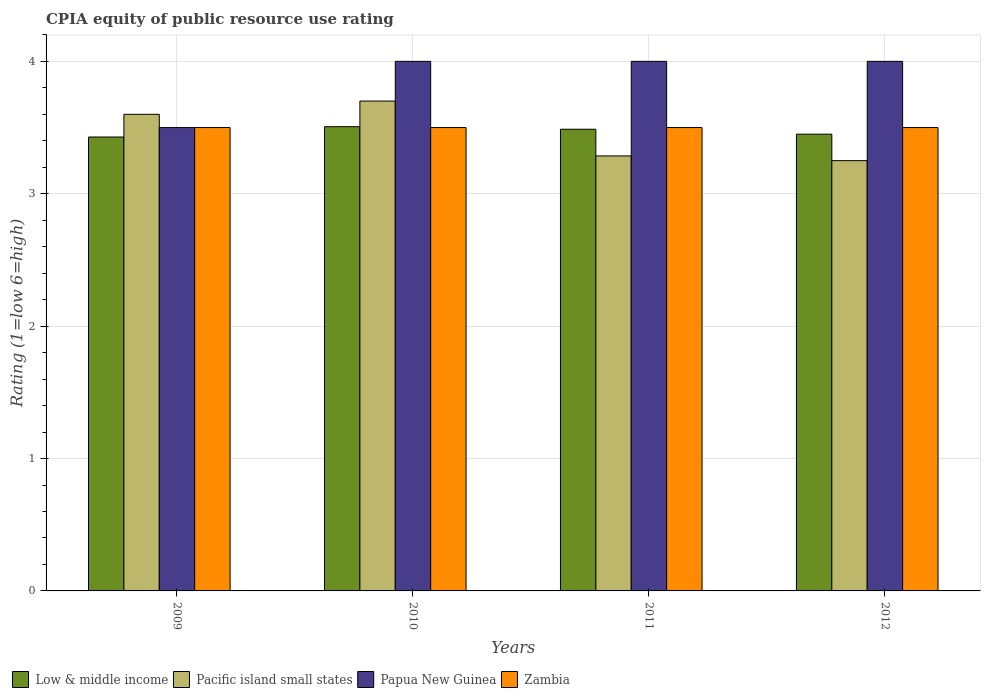Are the number of bars per tick equal to the number of legend labels?
Keep it short and to the point. Yes. Are the number of bars on each tick of the X-axis equal?
Offer a very short reply. Yes. What is the CPIA rating in Papua New Guinea in 2010?
Keep it short and to the point. 4. Across all years, what is the maximum CPIA rating in Low & middle income?
Provide a succinct answer. 3.51. Across all years, what is the minimum CPIA rating in Zambia?
Make the answer very short. 3.5. In which year was the CPIA rating in Papua New Guinea maximum?
Your answer should be compact. 2010. What is the total CPIA rating in Zambia in the graph?
Offer a terse response. 14. What is the difference between the CPIA rating in Zambia in 2010 and that in 2011?
Ensure brevity in your answer.  0. What is the difference between the CPIA rating in Papua New Guinea in 2011 and the CPIA rating in Zambia in 2012?
Provide a short and direct response. 0.5. What is the average CPIA rating in Pacific island small states per year?
Give a very brief answer. 3.46. In the year 2009, what is the difference between the CPIA rating in Zambia and CPIA rating in Pacific island small states?
Make the answer very short. -0.1. In how many years, is the CPIA rating in Zambia greater than 3.8?
Give a very brief answer. 0. Is the CPIA rating in Pacific island small states in 2009 less than that in 2011?
Make the answer very short. No. Is the difference between the CPIA rating in Zambia in 2009 and 2010 greater than the difference between the CPIA rating in Pacific island small states in 2009 and 2010?
Your answer should be compact. Yes. What is the difference between the highest and the second highest CPIA rating in Zambia?
Provide a succinct answer. 0. What is the difference between the highest and the lowest CPIA rating in Papua New Guinea?
Provide a short and direct response. 0.5. What does the 4th bar from the right in 2012 represents?
Offer a very short reply. Low & middle income. How many bars are there?
Provide a succinct answer. 16. Are all the bars in the graph horizontal?
Your response must be concise. No. Are the values on the major ticks of Y-axis written in scientific E-notation?
Ensure brevity in your answer.  No. Where does the legend appear in the graph?
Make the answer very short. Bottom left. How many legend labels are there?
Provide a succinct answer. 4. What is the title of the graph?
Your answer should be very brief. CPIA equity of public resource use rating. Does "Mongolia" appear as one of the legend labels in the graph?
Offer a terse response. No. What is the label or title of the Y-axis?
Keep it short and to the point. Rating (1=low 6=high). What is the Rating (1=low 6=high) in Low & middle income in 2009?
Keep it short and to the point. 3.43. What is the Rating (1=low 6=high) of Papua New Guinea in 2009?
Keep it short and to the point. 3.5. What is the Rating (1=low 6=high) of Zambia in 2009?
Give a very brief answer. 3.5. What is the Rating (1=low 6=high) in Low & middle income in 2010?
Give a very brief answer. 3.51. What is the Rating (1=low 6=high) of Papua New Guinea in 2010?
Provide a succinct answer. 4. What is the Rating (1=low 6=high) of Zambia in 2010?
Your answer should be compact. 3.5. What is the Rating (1=low 6=high) of Low & middle income in 2011?
Provide a short and direct response. 3.49. What is the Rating (1=low 6=high) of Pacific island small states in 2011?
Ensure brevity in your answer.  3.29. What is the Rating (1=low 6=high) in Papua New Guinea in 2011?
Your answer should be compact. 4. What is the Rating (1=low 6=high) of Low & middle income in 2012?
Ensure brevity in your answer.  3.45. What is the Rating (1=low 6=high) in Pacific island small states in 2012?
Keep it short and to the point. 3.25. What is the Rating (1=low 6=high) of Papua New Guinea in 2012?
Give a very brief answer. 4. What is the Rating (1=low 6=high) in Zambia in 2012?
Your response must be concise. 3.5. Across all years, what is the maximum Rating (1=low 6=high) of Low & middle income?
Ensure brevity in your answer.  3.51. Across all years, what is the maximum Rating (1=low 6=high) in Pacific island small states?
Provide a succinct answer. 3.7. Across all years, what is the maximum Rating (1=low 6=high) of Papua New Guinea?
Offer a terse response. 4. Across all years, what is the maximum Rating (1=low 6=high) in Zambia?
Give a very brief answer. 3.5. Across all years, what is the minimum Rating (1=low 6=high) of Low & middle income?
Make the answer very short. 3.43. Across all years, what is the minimum Rating (1=low 6=high) in Pacific island small states?
Ensure brevity in your answer.  3.25. What is the total Rating (1=low 6=high) of Low & middle income in the graph?
Your answer should be compact. 13.87. What is the total Rating (1=low 6=high) of Pacific island small states in the graph?
Ensure brevity in your answer.  13.84. What is the difference between the Rating (1=low 6=high) in Low & middle income in 2009 and that in 2010?
Provide a succinct answer. -0.08. What is the difference between the Rating (1=low 6=high) of Low & middle income in 2009 and that in 2011?
Your answer should be compact. -0.06. What is the difference between the Rating (1=low 6=high) of Pacific island small states in 2009 and that in 2011?
Make the answer very short. 0.31. What is the difference between the Rating (1=low 6=high) in Zambia in 2009 and that in 2011?
Provide a succinct answer. 0. What is the difference between the Rating (1=low 6=high) in Low & middle income in 2009 and that in 2012?
Your answer should be very brief. -0.02. What is the difference between the Rating (1=low 6=high) of Papua New Guinea in 2009 and that in 2012?
Provide a short and direct response. -0.5. What is the difference between the Rating (1=low 6=high) of Low & middle income in 2010 and that in 2011?
Give a very brief answer. 0.02. What is the difference between the Rating (1=low 6=high) in Pacific island small states in 2010 and that in 2011?
Provide a short and direct response. 0.41. What is the difference between the Rating (1=low 6=high) in Papua New Guinea in 2010 and that in 2011?
Your answer should be compact. 0. What is the difference between the Rating (1=low 6=high) of Low & middle income in 2010 and that in 2012?
Your answer should be very brief. 0.06. What is the difference between the Rating (1=low 6=high) in Pacific island small states in 2010 and that in 2012?
Keep it short and to the point. 0.45. What is the difference between the Rating (1=low 6=high) of Low & middle income in 2011 and that in 2012?
Offer a terse response. 0.04. What is the difference between the Rating (1=low 6=high) in Pacific island small states in 2011 and that in 2012?
Keep it short and to the point. 0.04. What is the difference between the Rating (1=low 6=high) in Zambia in 2011 and that in 2012?
Provide a succinct answer. 0. What is the difference between the Rating (1=low 6=high) in Low & middle income in 2009 and the Rating (1=low 6=high) in Pacific island small states in 2010?
Keep it short and to the point. -0.27. What is the difference between the Rating (1=low 6=high) in Low & middle income in 2009 and the Rating (1=low 6=high) in Papua New Guinea in 2010?
Provide a short and direct response. -0.57. What is the difference between the Rating (1=low 6=high) in Low & middle income in 2009 and the Rating (1=low 6=high) in Zambia in 2010?
Provide a short and direct response. -0.07. What is the difference between the Rating (1=low 6=high) of Pacific island small states in 2009 and the Rating (1=low 6=high) of Zambia in 2010?
Give a very brief answer. 0.1. What is the difference between the Rating (1=low 6=high) in Papua New Guinea in 2009 and the Rating (1=low 6=high) in Zambia in 2010?
Ensure brevity in your answer.  0. What is the difference between the Rating (1=low 6=high) in Low & middle income in 2009 and the Rating (1=low 6=high) in Pacific island small states in 2011?
Offer a very short reply. 0.14. What is the difference between the Rating (1=low 6=high) of Low & middle income in 2009 and the Rating (1=low 6=high) of Papua New Guinea in 2011?
Provide a short and direct response. -0.57. What is the difference between the Rating (1=low 6=high) in Low & middle income in 2009 and the Rating (1=low 6=high) in Zambia in 2011?
Offer a terse response. -0.07. What is the difference between the Rating (1=low 6=high) of Pacific island small states in 2009 and the Rating (1=low 6=high) of Papua New Guinea in 2011?
Your answer should be compact. -0.4. What is the difference between the Rating (1=low 6=high) of Papua New Guinea in 2009 and the Rating (1=low 6=high) of Zambia in 2011?
Keep it short and to the point. 0. What is the difference between the Rating (1=low 6=high) of Low & middle income in 2009 and the Rating (1=low 6=high) of Pacific island small states in 2012?
Ensure brevity in your answer.  0.18. What is the difference between the Rating (1=low 6=high) of Low & middle income in 2009 and the Rating (1=low 6=high) of Papua New Guinea in 2012?
Give a very brief answer. -0.57. What is the difference between the Rating (1=low 6=high) of Low & middle income in 2009 and the Rating (1=low 6=high) of Zambia in 2012?
Your answer should be very brief. -0.07. What is the difference between the Rating (1=low 6=high) of Low & middle income in 2010 and the Rating (1=low 6=high) of Pacific island small states in 2011?
Make the answer very short. 0.22. What is the difference between the Rating (1=low 6=high) of Low & middle income in 2010 and the Rating (1=low 6=high) of Papua New Guinea in 2011?
Your response must be concise. -0.49. What is the difference between the Rating (1=low 6=high) in Low & middle income in 2010 and the Rating (1=low 6=high) in Zambia in 2011?
Ensure brevity in your answer.  0.01. What is the difference between the Rating (1=low 6=high) of Pacific island small states in 2010 and the Rating (1=low 6=high) of Papua New Guinea in 2011?
Offer a terse response. -0.3. What is the difference between the Rating (1=low 6=high) in Pacific island small states in 2010 and the Rating (1=low 6=high) in Zambia in 2011?
Your answer should be very brief. 0.2. What is the difference between the Rating (1=low 6=high) in Papua New Guinea in 2010 and the Rating (1=low 6=high) in Zambia in 2011?
Ensure brevity in your answer.  0.5. What is the difference between the Rating (1=low 6=high) of Low & middle income in 2010 and the Rating (1=low 6=high) of Pacific island small states in 2012?
Your answer should be very brief. 0.26. What is the difference between the Rating (1=low 6=high) of Low & middle income in 2010 and the Rating (1=low 6=high) of Papua New Guinea in 2012?
Give a very brief answer. -0.49. What is the difference between the Rating (1=low 6=high) in Low & middle income in 2010 and the Rating (1=low 6=high) in Zambia in 2012?
Ensure brevity in your answer.  0.01. What is the difference between the Rating (1=low 6=high) of Pacific island small states in 2010 and the Rating (1=low 6=high) of Zambia in 2012?
Offer a very short reply. 0.2. What is the difference between the Rating (1=low 6=high) of Papua New Guinea in 2010 and the Rating (1=low 6=high) of Zambia in 2012?
Offer a very short reply. 0.5. What is the difference between the Rating (1=low 6=high) in Low & middle income in 2011 and the Rating (1=low 6=high) in Pacific island small states in 2012?
Provide a short and direct response. 0.24. What is the difference between the Rating (1=low 6=high) in Low & middle income in 2011 and the Rating (1=low 6=high) in Papua New Guinea in 2012?
Ensure brevity in your answer.  -0.51. What is the difference between the Rating (1=low 6=high) of Low & middle income in 2011 and the Rating (1=low 6=high) of Zambia in 2012?
Offer a very short reply. -0.01. What is the difference between the Rating (1=low 6=high) of Pacific island small states in 2011 and the Rating (1=low 6=high) of Papua New Guinea in 2012?
Offer a terse response. -0.71. What is the difference between the Rating (1=low 6=high) of Pacific island small states in 2011 and the Rating (1=low 6=high) of Zambia in 2012?
Your answer should be very brief. -0.21. What is the difference between the Rating (1=low 6=high) in Papua New Guinea in 2011 and the Rating (1=low 6=high) in Zambia in 2012?
Your answer should be very brief. 0.5. What is the average Rating (1=low 6=high) in Low & middle income per year?
Give a very brief answer. 3.47. What is the average Rating (1=low 6=high) in Pacific island small states per year?
Your response must be concise. 3.46. What is the average Rating (1=low 6=high) of Papua New Guinea per year?
Make the answer very short. 3.88. In the year 2009, what is the difference between the Rating (1=low 6=high) of Low & middle income and Rating (1=low 6=high) of Pacific island small states?
Offer a terse response. -0.17. In the year 2009, what is the difference between the Rating (1=low 6=high) in Low & middle income and Rating (1=low 6=high) in Papua New Guinea?
Your response must be concise. -0.07. In the year 2009, what is the difference between the Rating (1=low 6=high) of Low & middle income and Rating (1=low 6=high) of Zambia?
Offer a very short reply. -0.07. In the year 2009, what is the difference between the Rating (1=low 6=high) of Pacific island small states and Rating (1=low 6=high) of Papua New Guinea?
Offer a terse response. 0.1. In the year 2009, what is the difference between the Rating (1=low 6=high) in Pacific island small states and Rating (1=low 6=high) in Zambia?
Provide a short and direct response. 0.1. In the year 2010, what is the difference between the Rating (1=low 6=high) of Low & middle income and Rating (1=low 6=high) of Pacific island small states?
Make the answer very short. -0.19. In the year 2010, what is the difference between the Rating (1=low 6=high) of Low & middle income and Rating (1=low 6=high) of Papua New Guinea?
Offer a very short reply. -0.49. In the year 2010, what is the difference between the Rating (1=low 6=high) of Low & middle income and Rating (1=low 6=high) of Zambia?
Offer a very short reply. 0.01. In the year 2010, what is the difference between the Rating (1=low 6=high) in Pacific island small states and Rating (1=low 6=high) in Papua New Guinea?
Provide a short and direct response. -0.3. In the year 2010, what is the difference between the Rating (1=low 6=high) of Papua New Guinea and Rating (1=low 6=high) of Zambia?
Provide a short and direct response. 0.5. In the year 2011, what is the difference between the Rating (1=low 6=high) in Low & middle income and Rating (1=low 6=high) in Pacific island small states?
Provide a succinct answer. 0.2. In the year 2011, what is the difference between the Rating (1=low 6=high) of Low & middle income and Rating (1=low 6=high) of Papua New Guinea?
Your answer should be compact. -0.51. In the year 2011, what is the difference between the Rating (1=low 6=high) of Low & middle income and Rating (1=low 6=high) of Zambia?
Make the answer very short. -0.01. In the year 2011, what is the difference between the Rating (1=low 6=high) in Pacific island small states and Rating (1=low 6=high) in Papua New Guinea?
Offer a terse response. -0.71. In the year 2011, what is the difference between the Rating (1=low 6=high) of Pacific island small states and Rating (1=low 6=high) of Zambia?
Offer a terse response. -0.21. In the year 2011, what is the difference between the Rating (1=low 6=high) of Papua New Guinea and Rating (1=low 6=high) of Zambia?
Offer a very short reply. 0.5. In the year 2012, what is the difference between the Rating (1=low 6=high) in Low & middle income and Rating (1=low 6=high) in Pacific island small states?
Your response must be concise. 0.2. In the year 2012, what is the difference between the Rating (1=low 6=high) in Low & middle income and Rating (1=low 6=high) in Papua New Guinea?
Provide a succinct answer. -0.55. In the year 2012, what is the difference between the Rating (1=low 6=high) of Pacific island small states and Rating (1=low 6=high) of Papua New Guinea?
Your response must be concise. -0.75. In the year 2012, what is the difference between the Rating (1=low 6=high) in Pacific island small states and Rating (1=low 6=high) in Zambia?
Your answer should be very brief. -0.25. What is the ratio of the Rating (1=low 6=high) of Low & middle income in 2009 to that in 2010?
Offer a terse response. 0.98. What is the ratio of the Rating (1=low 6=high) of Pacific island small states in 2009 to that in 2010?
Make the answer very short. 0.97. What is the ratio of the Rating (1=low 6=high) of Zambia in 2009 to that in 2010?
Offer a very short reply. 1. What is the ratio of the Rating (1=low 6=high) of Low & middle income in 2009 to that in 2011?
Ensure brevity in your answer.  0.98. What is the ratio of the Rating (1=low 6=high) in Pacific island small states in 2009 to that in 2011?
Make the answer very short. 1.1. What is the ratio of the Rating (1=low 6=high) in Papua New Guinea in 2009 to that in 2011?
Give a very brief answer. 0.88. What is the ratio of the Rating (1=low 6=high) in Zambia in 2009 to that in 2011?
Offer a very short reply. 1. What is the ratio of the Rating (1=low 6=high) in Low & middle income in 2009 to that in 2012?
Ensure brevity in your answer.  0.99. What is the ratio of the Rating (1=low 6=high) of Pacific island small states in 2009 to that in 2012?
Keep it short and to the point. 1.11. What is the ratio of the Rating (1=low 6=high) of Papua New Guinea in 2009 to that in 2012?
Offer a very short reply. 0.88. What is the ratio of the Rating (1=low 6=high) of Zambia in 2009 to that in 2012?
Your answer should be very brief. 1. What is the ratio of the Rating (1=low 6=high) in Low & middle income in 2010 to that in 2011?
Your answer should be compact. 1.01. What is the ratio of the Rating (1=low 6=high) of Pacific island small states in 2010 to that in 2011?
Your answer should be compact. 1.13. What is the ratio of the Rating (1=low 6=high) of Papua New Guinea in 2010 to that in 2011?
Provide a succinct answer. 1. What is the ratio of the Rating (1=low 6=high) of Zambia in 2010 to that in 2011?
Offer a terse response. 1. What is the ratio of the Rating (1=low 6=high) of Low & middle income in 2010 to that in 2012?
Your answer should be very brief. 1.02. What is the ratio of the Rating (1=low 6=high) of Pacific island small states in 2010 to that in 2012?
Offer a very short reply. 1.14. What is the ratio of the Rating (1=low 6=high) in Papua New Guinea in 2010 to that in 2012?
Ensure brevity in your answer.  1. What is the ratio of the Rating (1=low 6=high) of Low & middle income in 2011 to that in 2012?
Your answer should be compact. 1.01. What is the ratio of the Rating (1=low 6=high) in Pacific island small states in 2011 to that in 2012?
Make the answer very short. 1.01. What is the difference between the highest and the second highest Rating (1=low 6=high) in Low & middle income?
Offer a very short reply. 0.02. What is the difference between the highest and the second highest Rating (1=low 6=high) in Pacific island small states?
Keep it short and to the point. 0.1. What is the difference between the highest and the second highest Rating (1=low 6=high) in Papua New Guinea?
Your response must be concise. 0. What is the difference between the highest and the second highest Rating (1=low 6=high) of Zambia?
Ensure brevity in your answer.  0. What is the difference between the highest and the lowest Rating (1=low 6=high) in Low & middle income?
Ensure brevity in your answer.  0.08. What is the difference between the highest and the lowest Rating (1=low 6=high) in Pacific island small states?
Your response must be concise. 0.45. What is the difference between the highest and the lowest Rating (1=low 6=high) of Zambia?
Provide a short and direct response. 0. 